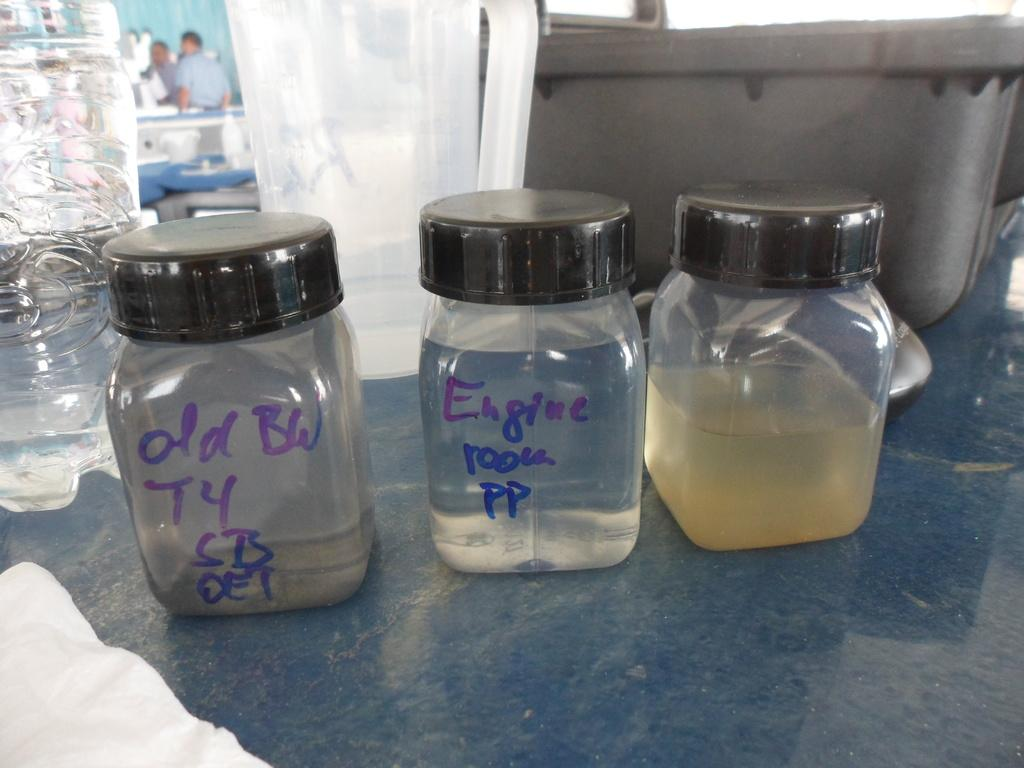<image>
Present a compact description of the photo's key features. Jars of cloudy liquid, one is marked Engine Room PP. 